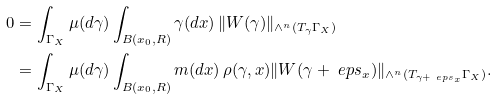Convert formula to latex. <formula><loc_0><loc_0><loc_500><loc_500>0 & = \int _ { \Gamma _ { X } } \mu ( d \gamma ) \int _ { B ( x _ { 0 } , R ) } \gamma ( d x ) \, \| W ( \gamma ) \| _ { \wedge ^ { n } ( T _ { \gamma } \Gamma _ { X } ) } \\ & = \int _ { \Gamma _ { X } } \mu ( d \gamma ) \int _ { B ( x _ { 0 } , R ) } m ( d x ) \, \rho ( \gamma , x ) \| W ( \gamma + \ e p s _ { x } ) \| _ { \wedge ^ { n } ( T _ { \gamma + \ e p s _ { x } } \Gamma _ { X } ) } .</formula> 